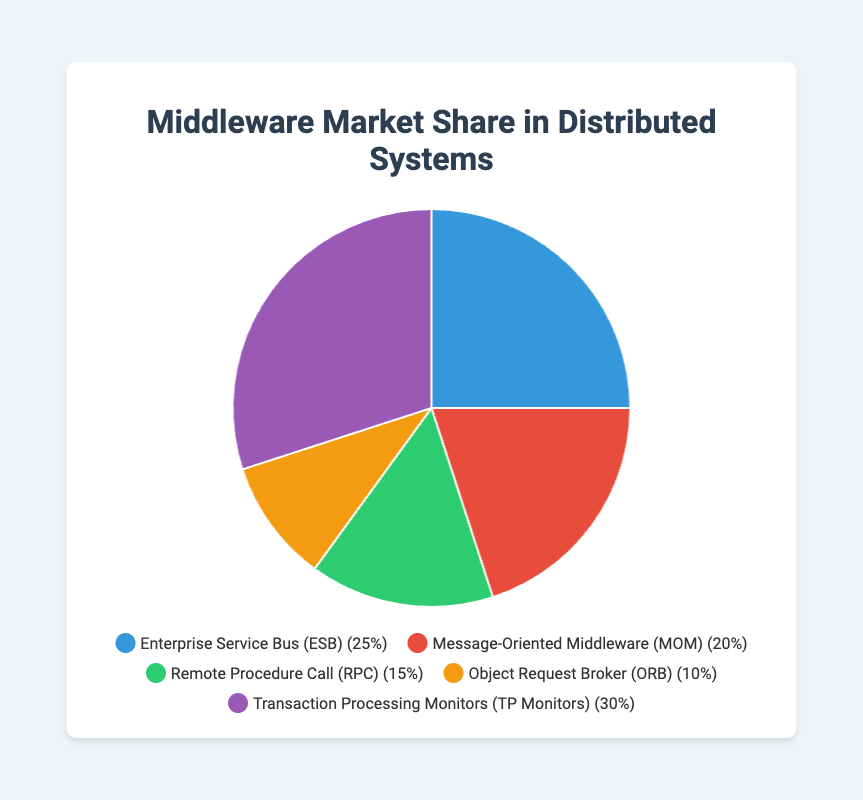Which type of middleware has the largest market share? The figure shows that "Transaction Processing Monitors (TP Monitors)" has the largest slice of the pie chart, indicating that it has the largest market share.
Answer: Transaction Processing Monitors (TP Monitors) How much more market share does "Enterprise Service Bus (ESB)" have than "Object Request Broker (ORB)"? "Enterprise Service Bus (ESB)" has a market share of 25%, and "Object Request Broker (ORB)" has a market share of 10%. The difference is 25% - 10%.
Answer: 15% Which two types of middleware have the smallest combined market share? The two types of middleware with the smallest slices in the pie chart are "Remote Procedure Call (RPC)" and "Object Request Broker (ORB)" with 15% and 10% respectively. Their combined market share is 15% + 10%.
Answer: 25% What is the total market share of the types of middleware that have more than 20% share each? "Transaction Processing Monitors (TP Monitors)" has 30% and "Enterprise Service Bus (ESB)" has 25%. Their combined market share is 30% + 25%.
Answer: 55% Which middleware type has the third largest market share and what is its percentage? The third largest slice in the pie chart corresponds to "Remote Procedure Call (RPC)", which has a market share of 15%.
Answer: Remote Procedure Call (RPC), 15% How much greater is the market share of "Transaction Processing Monitors (TP Monitors)" compared to "Message-Oriented Middleware (MOM)"? "Transaction Processing Monitors (TP Monitors)" has a market share of 30%, while "Message-Oriented Middleware (MOM)" has 20%. The difference is 30% - 20%.
Answer: 10% What is the average market share of all middleware types shown in the figure? The total market share of all types is 25% + 20% + 15% + 10% + 30% = 100%. There are 5 types, so the average market share is 100% / 5.
Answer: 20% What is the combined market share of "Message-Oriented Middleware (MOM)" and "Remote Procedure Call (RPC)"? "Message-Oriented Middleware (MOM)" has a market share of 20%, and "Remote Procedure Call (RPC)" has 15%. Their combined market share is 20% + 15%.
Answer: 35% Which middleware type is represented with the smallest slice in the pie chart, and what is its market share? The smallest slice in the pie chart corresponds to "Object Request Broker (ORB)", which has a market share of 10%.
Answer: Object Request Broker (ORB), 10% 